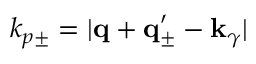Convert formula to latex. <formula><loc_0><loc_0><loc_500><loc_500>k _ { p \pm } = | { q } + { q } _ { \pm } ^ { \prime } - { k } _ { \gamma } |</formula> 